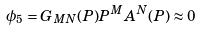<formula> <loc_0><loc_0><loc_500><loc_500>\phi _ { 5 } = G _ { M N } ( P ) P ^ { M } A ^ { N } ( P ) \approx 0</formula> 